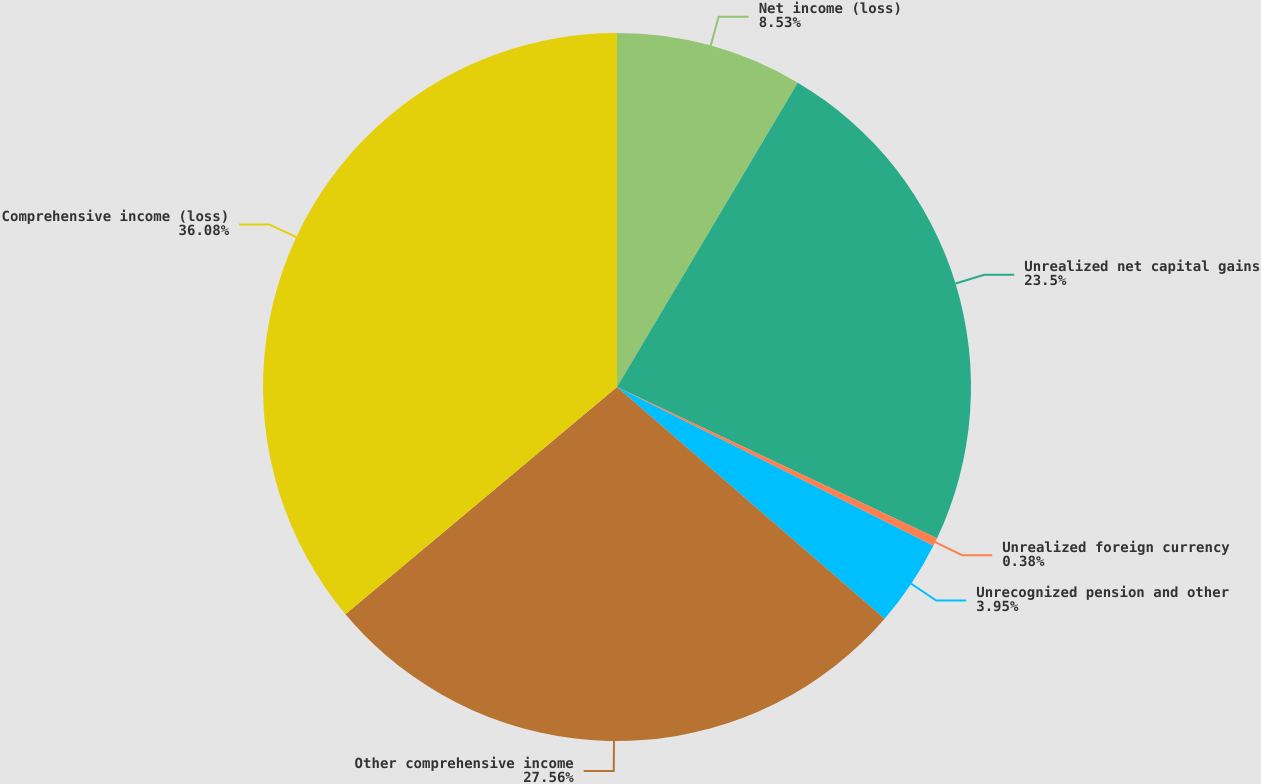<chart> <loc_0><loc_0><loc_500><loc_500><pie_chart><fcel>Net income (loss)<fcel>Unrealized net capital gains<fcel>Unrealized foreign currency<fcel>Unrecognized pension and other<fcel>Other comprehensive income<fcel>Comprehensive income (loss)<nl><fcel>8.53%<fcel>23.5%<fcel>0.38%<fcel>3.95%<fcel>27.56%<fcel>36.09%<nl></chart> 